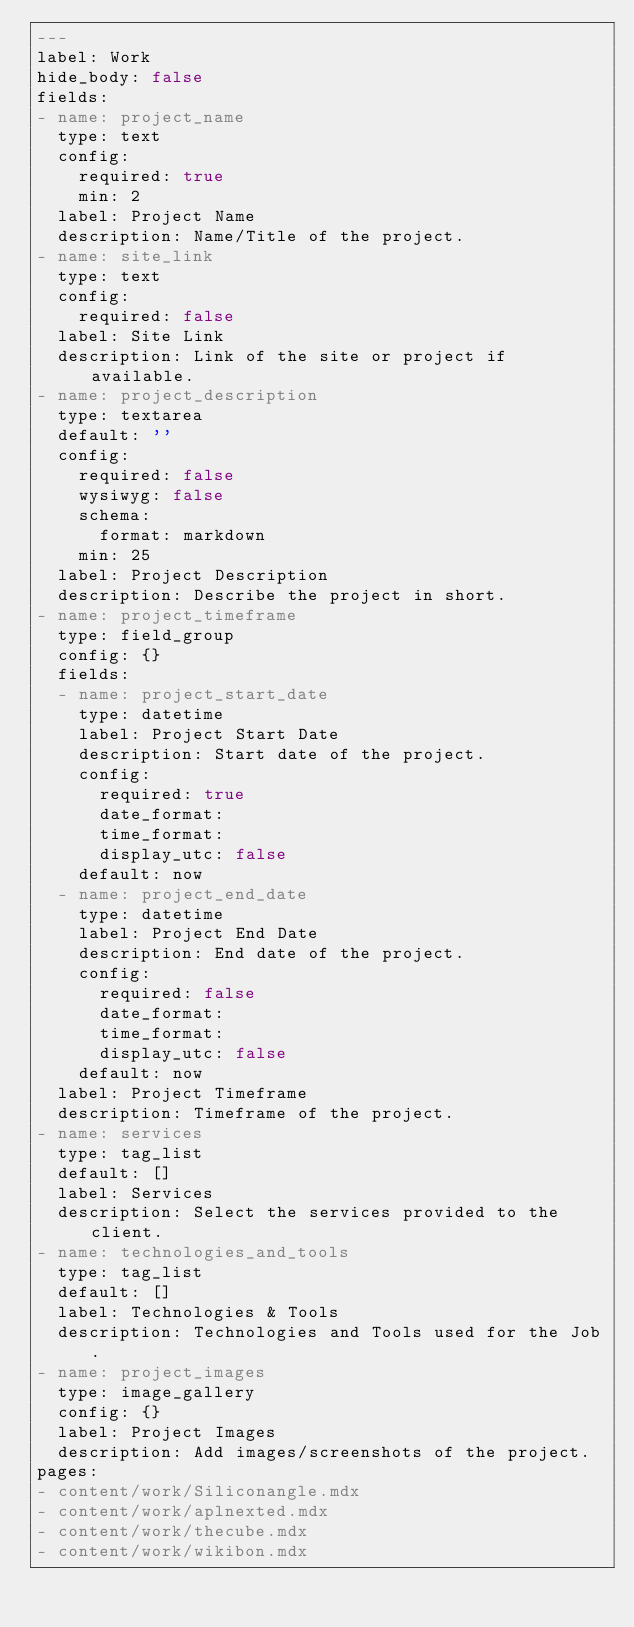Convert code to text. <code><loc_0><loc_0><loc_500><loc_500><_YAML_>---
label: Work
hide_body: false
fields:
- name: project_name
  type: text
  config:
    required: true
    min: 2
  label: Project Name
  description: Name/Title of the project.
- name: site_link
  type: text
  config:
    required: false
  label: Site Link
  description: Link of the site or project if available.
- name: project_description
  type: textarea
  default: ''
  config:
    required: false
    wysiwyg: false
    schema:
      format: markdown
    min: 25
  label: Project Description
  description: Describe the project in short.
- name: project_timeframe
  type: field_group
  config: {}
  fields:
  - name: project_start_date
    type: datetime
    label: Project Start Date
    description: Start date of the project.
    config:
      required: true
      date_format: 
      time_format: 
      display_utc: false
    default: now
  - name: project_end_date
    type: datetime
    label: Project End Date
    description: End date of the project.
    config:
      required: false
      date_format: 
      time_format: 
      display_utc: false
    default: now
  label: Project Timeframe
  description: Timeframe of the project.
- name: services
  type: tag_list
  default: []
  label: Services
  description: Select the services provided to the client.
- name: technologies_and_tools
  type: tag_list
  default: []
  label: Technologies & Tools
  description: Technologies and Tools used for the Job.
- name: project_images
  type: image_gallery
  config: {}
  label: Project Images
  description: Add images/screenshots of the project.
pages:
- content/work/Siliconangle.mdx
- content/work/aplnexted.mdx
- content/work/thecube.mdx
- content/work/wikibon.mdx
</code> 